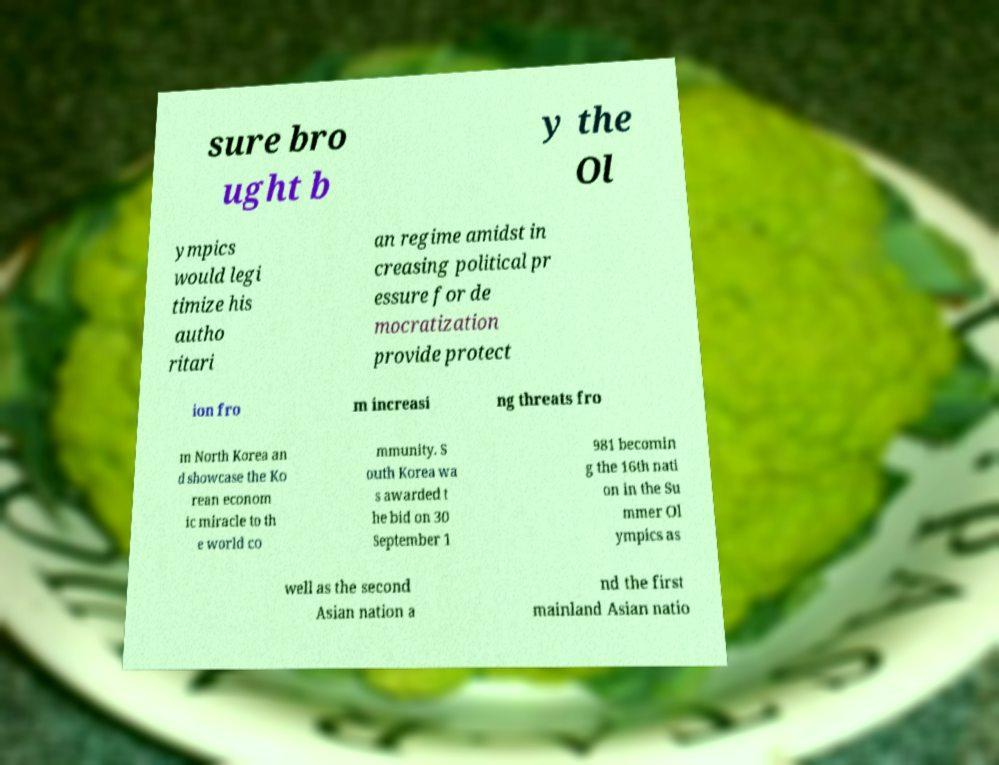There's text embedded in this image that I need extracted. Can you transcribe it verbatim? sure bro ught b y the Ol ympics would legi timize his autho ritari an regime amidst in creasing political pr essure for de mocratization provide protect ion fro m increasi ng threats fro m North Korea an d showcase the Ko rean econom ic miracle to th e world co mmunity. S outh Korea wa s awarded t he bid on 30 September 1 981 becomin g the 16th nati on in the Su mmer Ol ympics as well as the second Asian nation a nd the first mainland Asian natio 